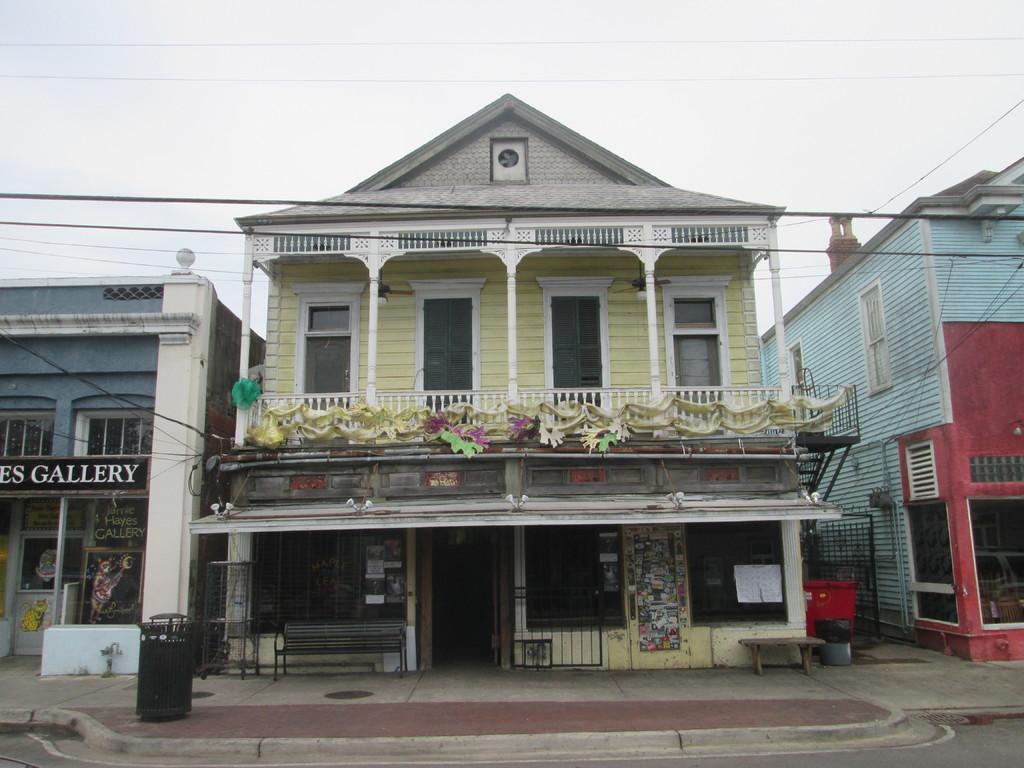Can you describe this image briefly? In this image there are buildings, in front of the building there is a footpath and there are benches. 